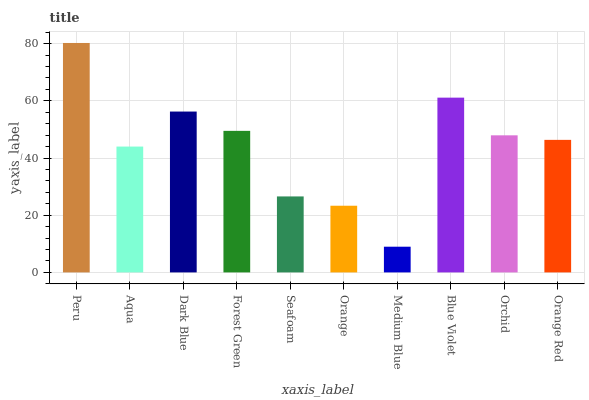Is Medium Blue the minimum?
Answer yes or no. Yes. Is Peru the maximum?
Answer yes or no. Yes. Is Aqua the minimum?
Answer yes or no. No. Is Aqua the maximum?
Answer yes or no. No. Is Peru greater than Aqua?
Answer yes or no. Yes. Is Aqua less than Peru?
Answer yes or no. Yes. Is Aqua greater than Peru?
Answer yes or no. No. Is Peru less than Aqua?
Answer yes or no. No. Is Orchid the high median?
Answer yes or no. Yes. Is Orange Red the low median?
Answer yes or no. Yes. Is Orange Red the high median?
Answer yes or no. No. Is Forest Green the low median?
Answer yes or no. No. 